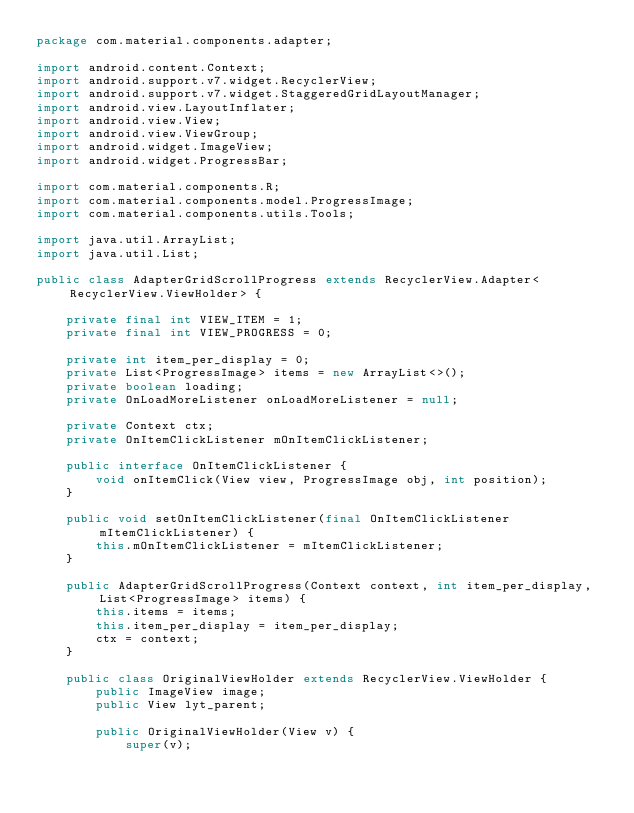<code> <loc_0><loc_0><loc_500><loc_500><_Java_>package com.material.components.adapter;

import android.content.Context;
import android.support.v7.widget.RecyclerView;
import android.support.v7.widget.StaggeredGridLayoutManager;
import android.view.LayoutInflater;
import android.view.View;
import android.view.ViewGroup;
import android.widget.ImageView;
import android.widget.ProgressBar;

import com.material.components.R;
import com.material.components.model.ProgressImage;
import com.material.components.utils.Tools;

import java.util.ArrayList;
import java.util.List;

public class AdapterGridScrollProgress extends RecyclerView.Adapter<RecyclerView.ViewHolder> {

    private final int VIEW_ITEM = 1;
    private final int VIEW_PROGRESS = 0;

    private int item_per_display = 0;
    private List<ProgressImage> items = new ArrayList<>();
    private boolean loading;
    private OnLoadMoreListener onLoadMoreListener = null;

    private Context ctx;
    private OnItemClickListener mOnItemClickListener;

    public interface OnItemClickListener {
        void onItemClick(View view, ProgressImage obj, int position);
    }

    public void setOnItemClickListener(final OnItemClickListener mItemClickListener) {
        this.mOnItemClickListener = mItemClickListener;
    }

    public AdapterGridScrollProgress(Context context, int item_per_display, List<ProgressImage> items) {
        this.items = items;
        this.item_per_display = item_per_display;
        ctx = context;
    }

    public class OriginalViewHolder extends RecyclerView.ViewHolder {
        public ImageView image;
        public View lyt_parent;

        public OriginalViewHolder(View v) {
            super(v);</code> 